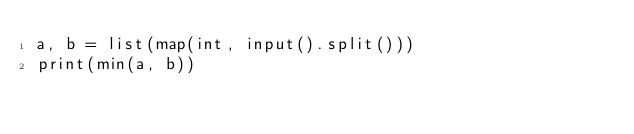Convert code to text. <code><loc_0><loc_0><loc_500><loc_500><_Python_>a, b = list(map(int, input().split()))
print(min(a, b))</code> 